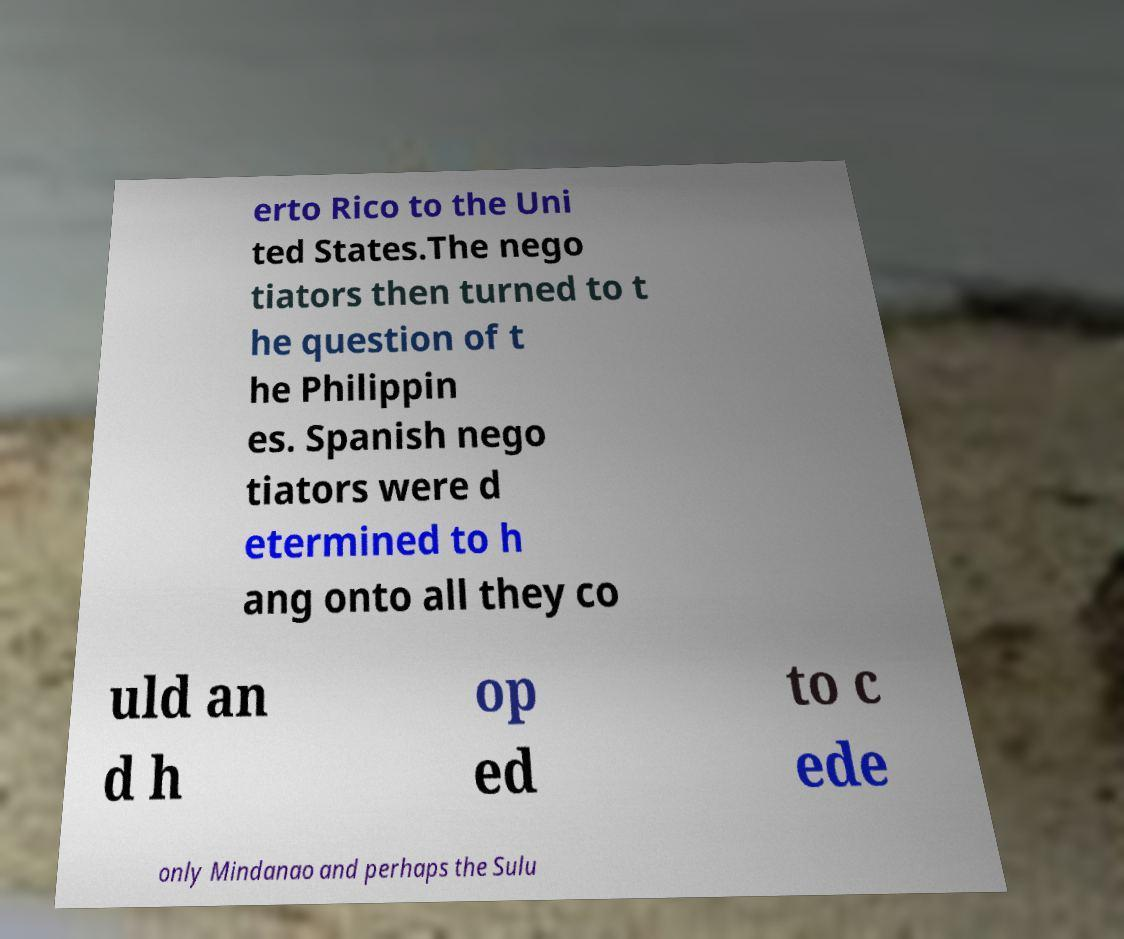Could you assist in decoding the text presented in this image and type it out clearly? erto Rico to the Uni ted States.The nego tiators then turned to t he question of t he Philippin es. Spanish nego tiators were d etermined to h ang onto all they co uld an d h op ed to c ede only Mindanao and perhaps the Sulu 